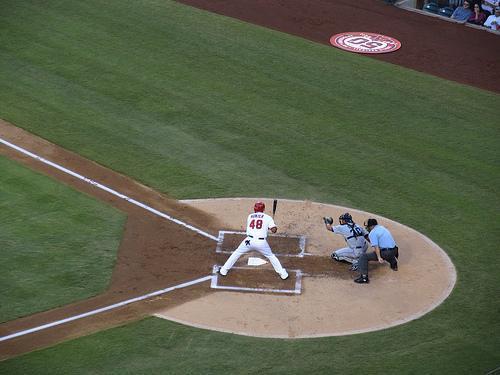How many players in the field?
Give a very brief answer. 3. 